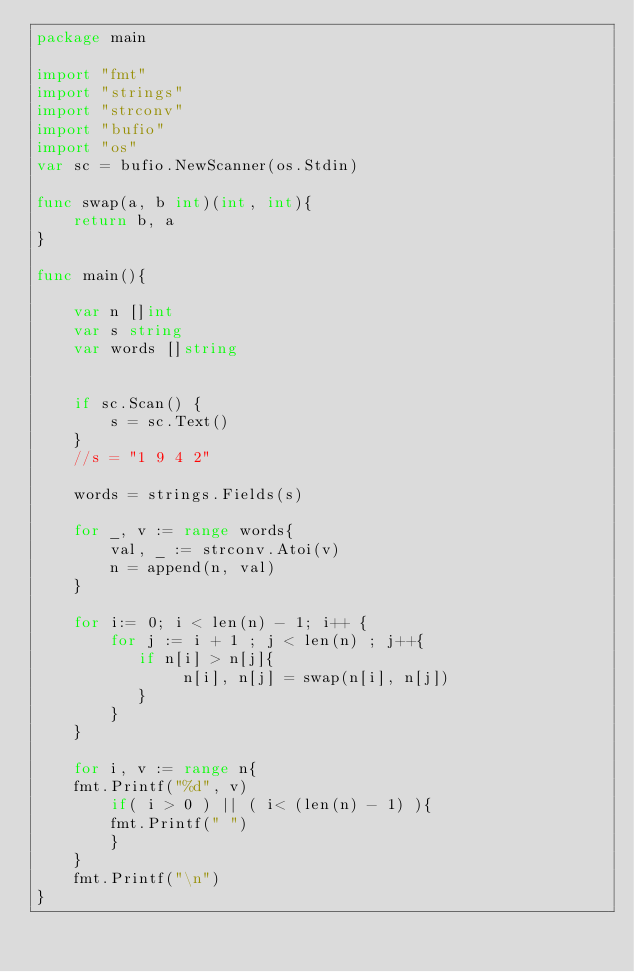Convert code to text. <code><loc_0><loc_0><loc_500><loc_500><_Go_>package main

import "fmt"
import "strings"
import "strconv"
import "bufio"
import "os"
var sc = bufio.NewScanner(os.Stdin)

func swap(a, b int)(int, int){
    return b, a 
}

func main(){

    var n []int
    var s string
    var words []string
    
    
    if sc.Scan() {
        s = sc.Text()
    }
    //s = "1 9 4 2"    

    words = strings.Fields(s) 

    for _, v := range words{
        val, _ := strconv.Atoi(v) 
        n = append(n, val) 
    }
 
    for i:= 0; i < len(n) - 1; i++ {
        for j := i + 1 ; j < len(n) ; j++{
           if n[i] > n[j]{
                n[i], n[j] = swap(n[i], n[j])
           }
        }
    } 
    
    for i, v := range n{
	fmt.Printf("%d", v)
        if( i > 0 ) || ( i< (len(n) - 1) ){
        fmt.Printf(" ")
        }
    }
    fmt.Printf("\n")
}
</code> 